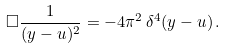<formula> <loc_0><loc_0><loc_500><loc_500>\Box \frac { 1 } { ( y - u ) ^ { 2 } } = - 4 \pi ^ { 2 } \, \delta ^ { 4 } ( y - u ) \, .</formula> 